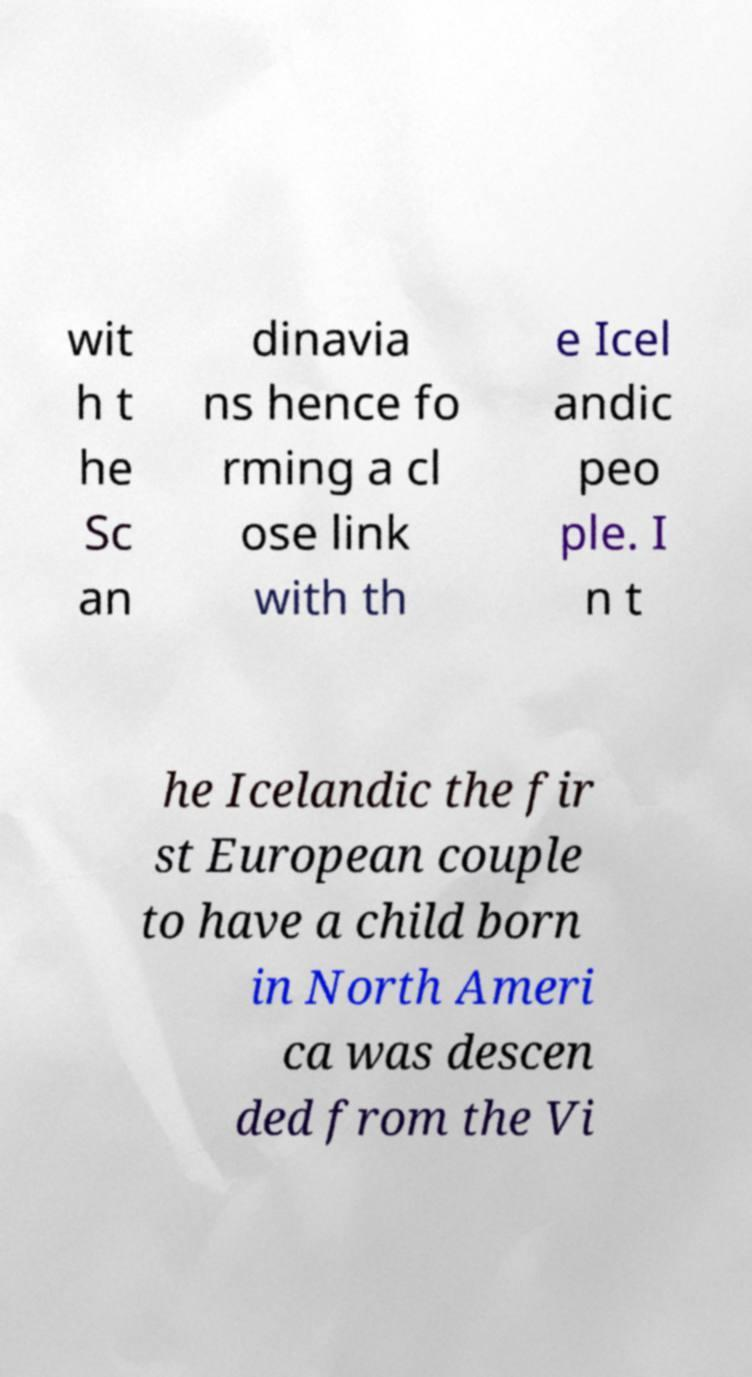There's text embedded in this image that I need extracted. Can you transcribe it verbatim? wit h t he Sc an dinavia ns hence fo rming a cl ose link with th e Icel andic peo ple. I n t he Icelandic the fir st European couple to have a child born in North Ameri ca was descen ded from the Vi 